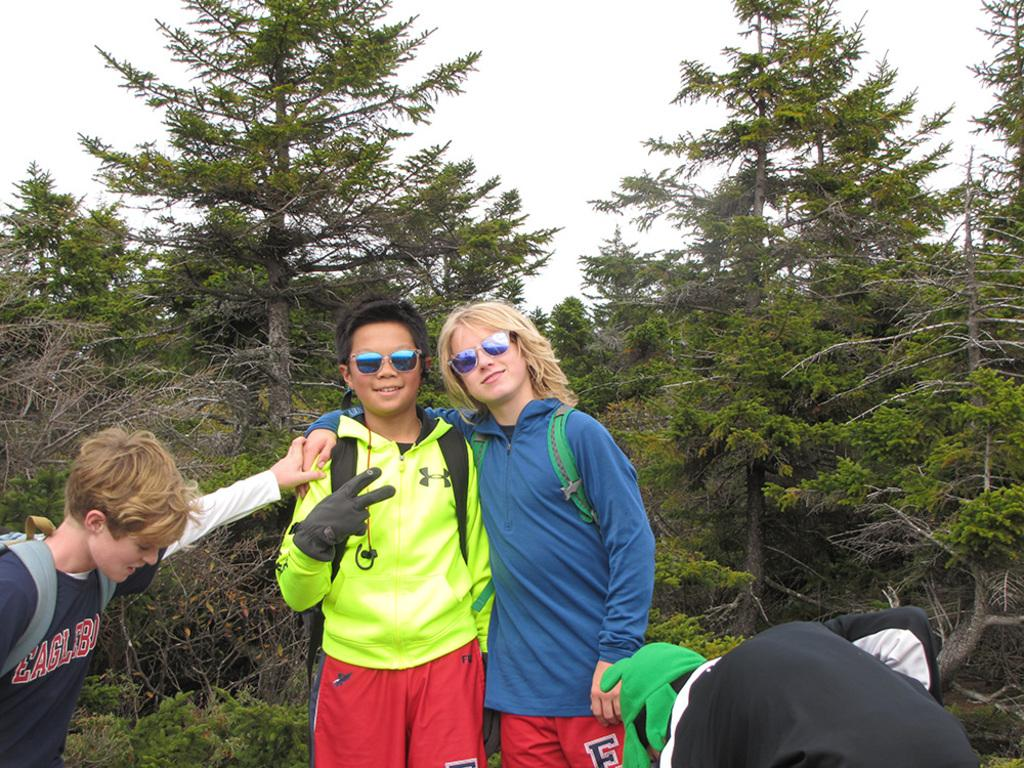How many people are in the image? There are people in the image, but the exact number is not specified. What are two of the people wearing? Two of the people are wearing goggles. What are three of the people wearing? Three of the people are wearing backpacks. What can be seen in the background of the image? There are trees and the sky visible in the background of the image. What type of tin can be seen in the image? There is no tin present in the image. How many lizards are sitting on the people's backpacks in the image? There are no lizards present in the image. 